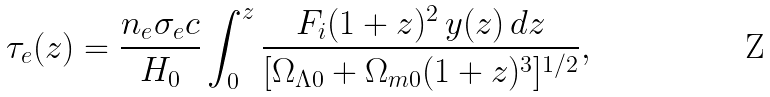<formula> <loc_0><loc_0><loc_500><loc_500>\tau _ { e } ( z ) = \frac { n _ { e } \sigma _ { e } c } { H _ { 0 } } \int _ { 0 } ^ { z } \frac { F _ { i } ( 1 + z ) ^ { 2 } \, y ( z ) \, d z } { [ \Omega _ { \Lambda 0 } + \Omega _ { m 0 } ( 1 + z ) ^ { 3 } ] ^ { 1 / 2 } } ,</formula> 